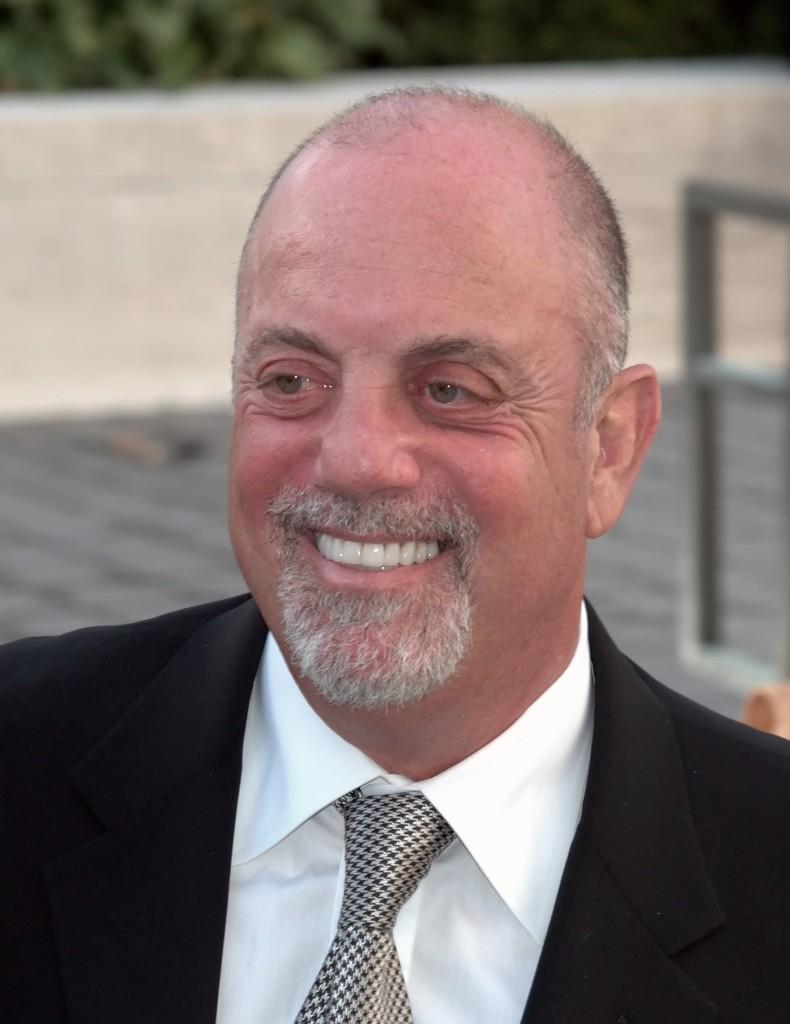Who is present in the image? There is a man in the image. What is the man wearing? The man is wearing a black suit, a white shirt, and a tie. What can be seen in the background of the image? There is a wall and trees in the background of the image. What type of cork can be seen in the man's hand in the image? There is no cork present in the image; the man is not holding anything in his hand. 